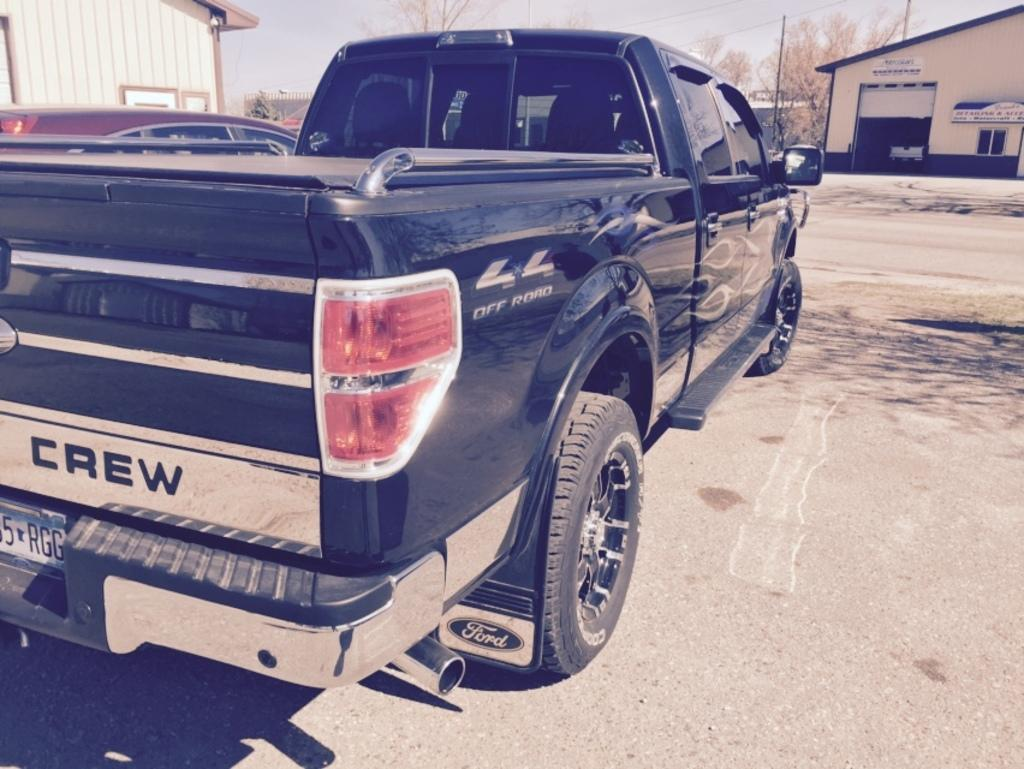What is the main subject of the image? There is a vehicle in the image. Can you describe the structures in the top corners of the image? There are shelter houses in the top right and top left of the image. What type of natural elements can be seen at the top of the image? Trees are visible at the top of the image. What is visible in the background of the image? The sky is visible at the top of the image. What type of glue is being used to hold the dinner together in the image? There is no dinner or glue present in the image. Where is the middle of the image located? The concept of a "middle" of the image is not applicable, as the image is a two-dimensional representation. 